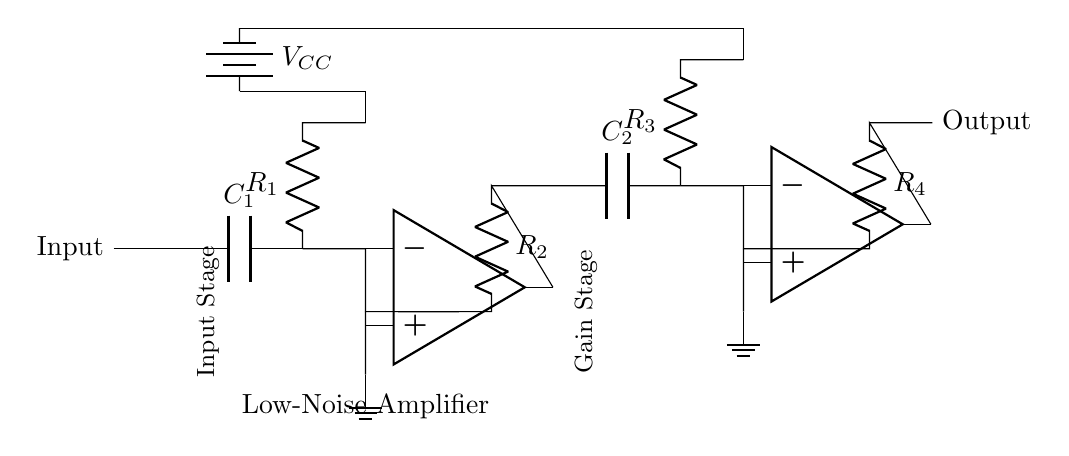What is the value of the capacitor C1? The capacitor C1 is labeled in the circuit diagram, but its value isn't specified in the text. Therefore, it can be assumed to be not defined here.
Answer: Not defined What is the total number of resistors in the circuit? There are four resistors labeled R1, R2, R3, and R4 in the circuit diagram. Each can be counted to confirm the total number.
Answer: Four What connects the input to the first op-amp in the circuit? The input is initially connected to a capacitor C1, which charges and allows for signal processing. The capacitor acts as a coupling element between input and the amplifier.
Answer: C1 What type of circuit is presented? The circuit is a low-noise amplifier, indicated by its label as well as the configuration of the operational amplifiers enhancing signal integrity.
Answer: Low-noise amplifier How many stages does the amplifier have? The circuit diagram has two stages: an input stage and a gain stage, as indicated by the labels in the diagram.
Answer: Two What is the role of the op-amps in the circuit? The op-amps amplify the input signal, improving gain and minimizing noise, enhancing the overall quality of the transmitted signal.
Answer: Amplification What is the power supply voltage labeled in the circuit? The voltage supply is indicated as VCC in the circuit diagram, but the exact voltage value is not shown in the provided information.
Answer: Not defined 